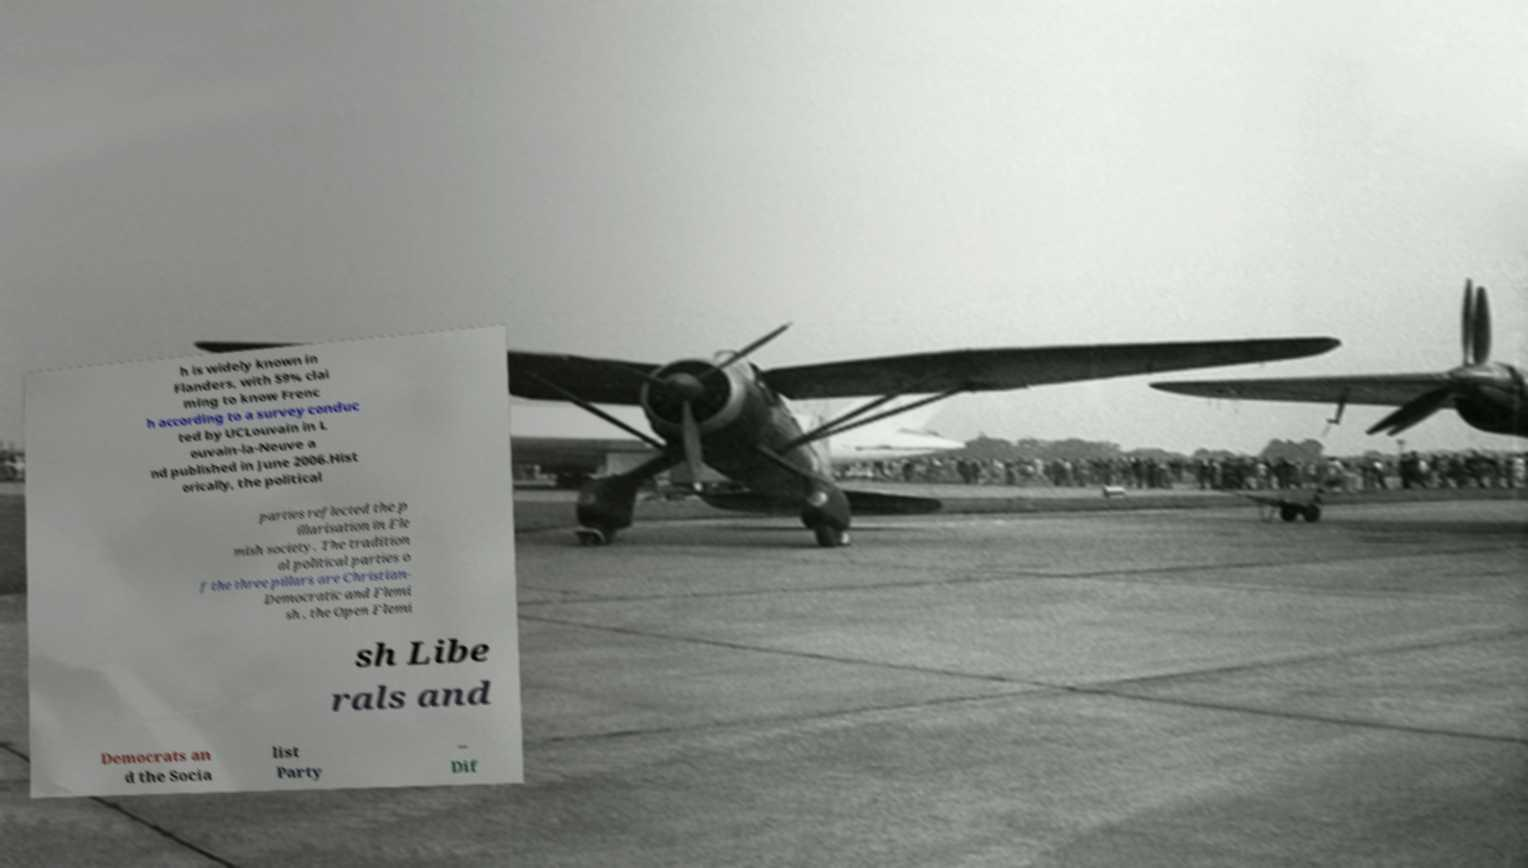Can you accurately transcribe the text from the provided image for me? h is widely known in Flanders, with 59% clai ming to know Frenc h according to a survey conduc ted by UCLouvain in L ouvain-la-Neuve a nd published in June 2006.Hist orically, the political parties reflected the p illarisation in Fle mish society. The tradition al political parties o f the three pillars are Christian- Democratic and Flemi sh , the Open Flemi sh Libe rals and Democrats an d the Socia list Party – Dif 